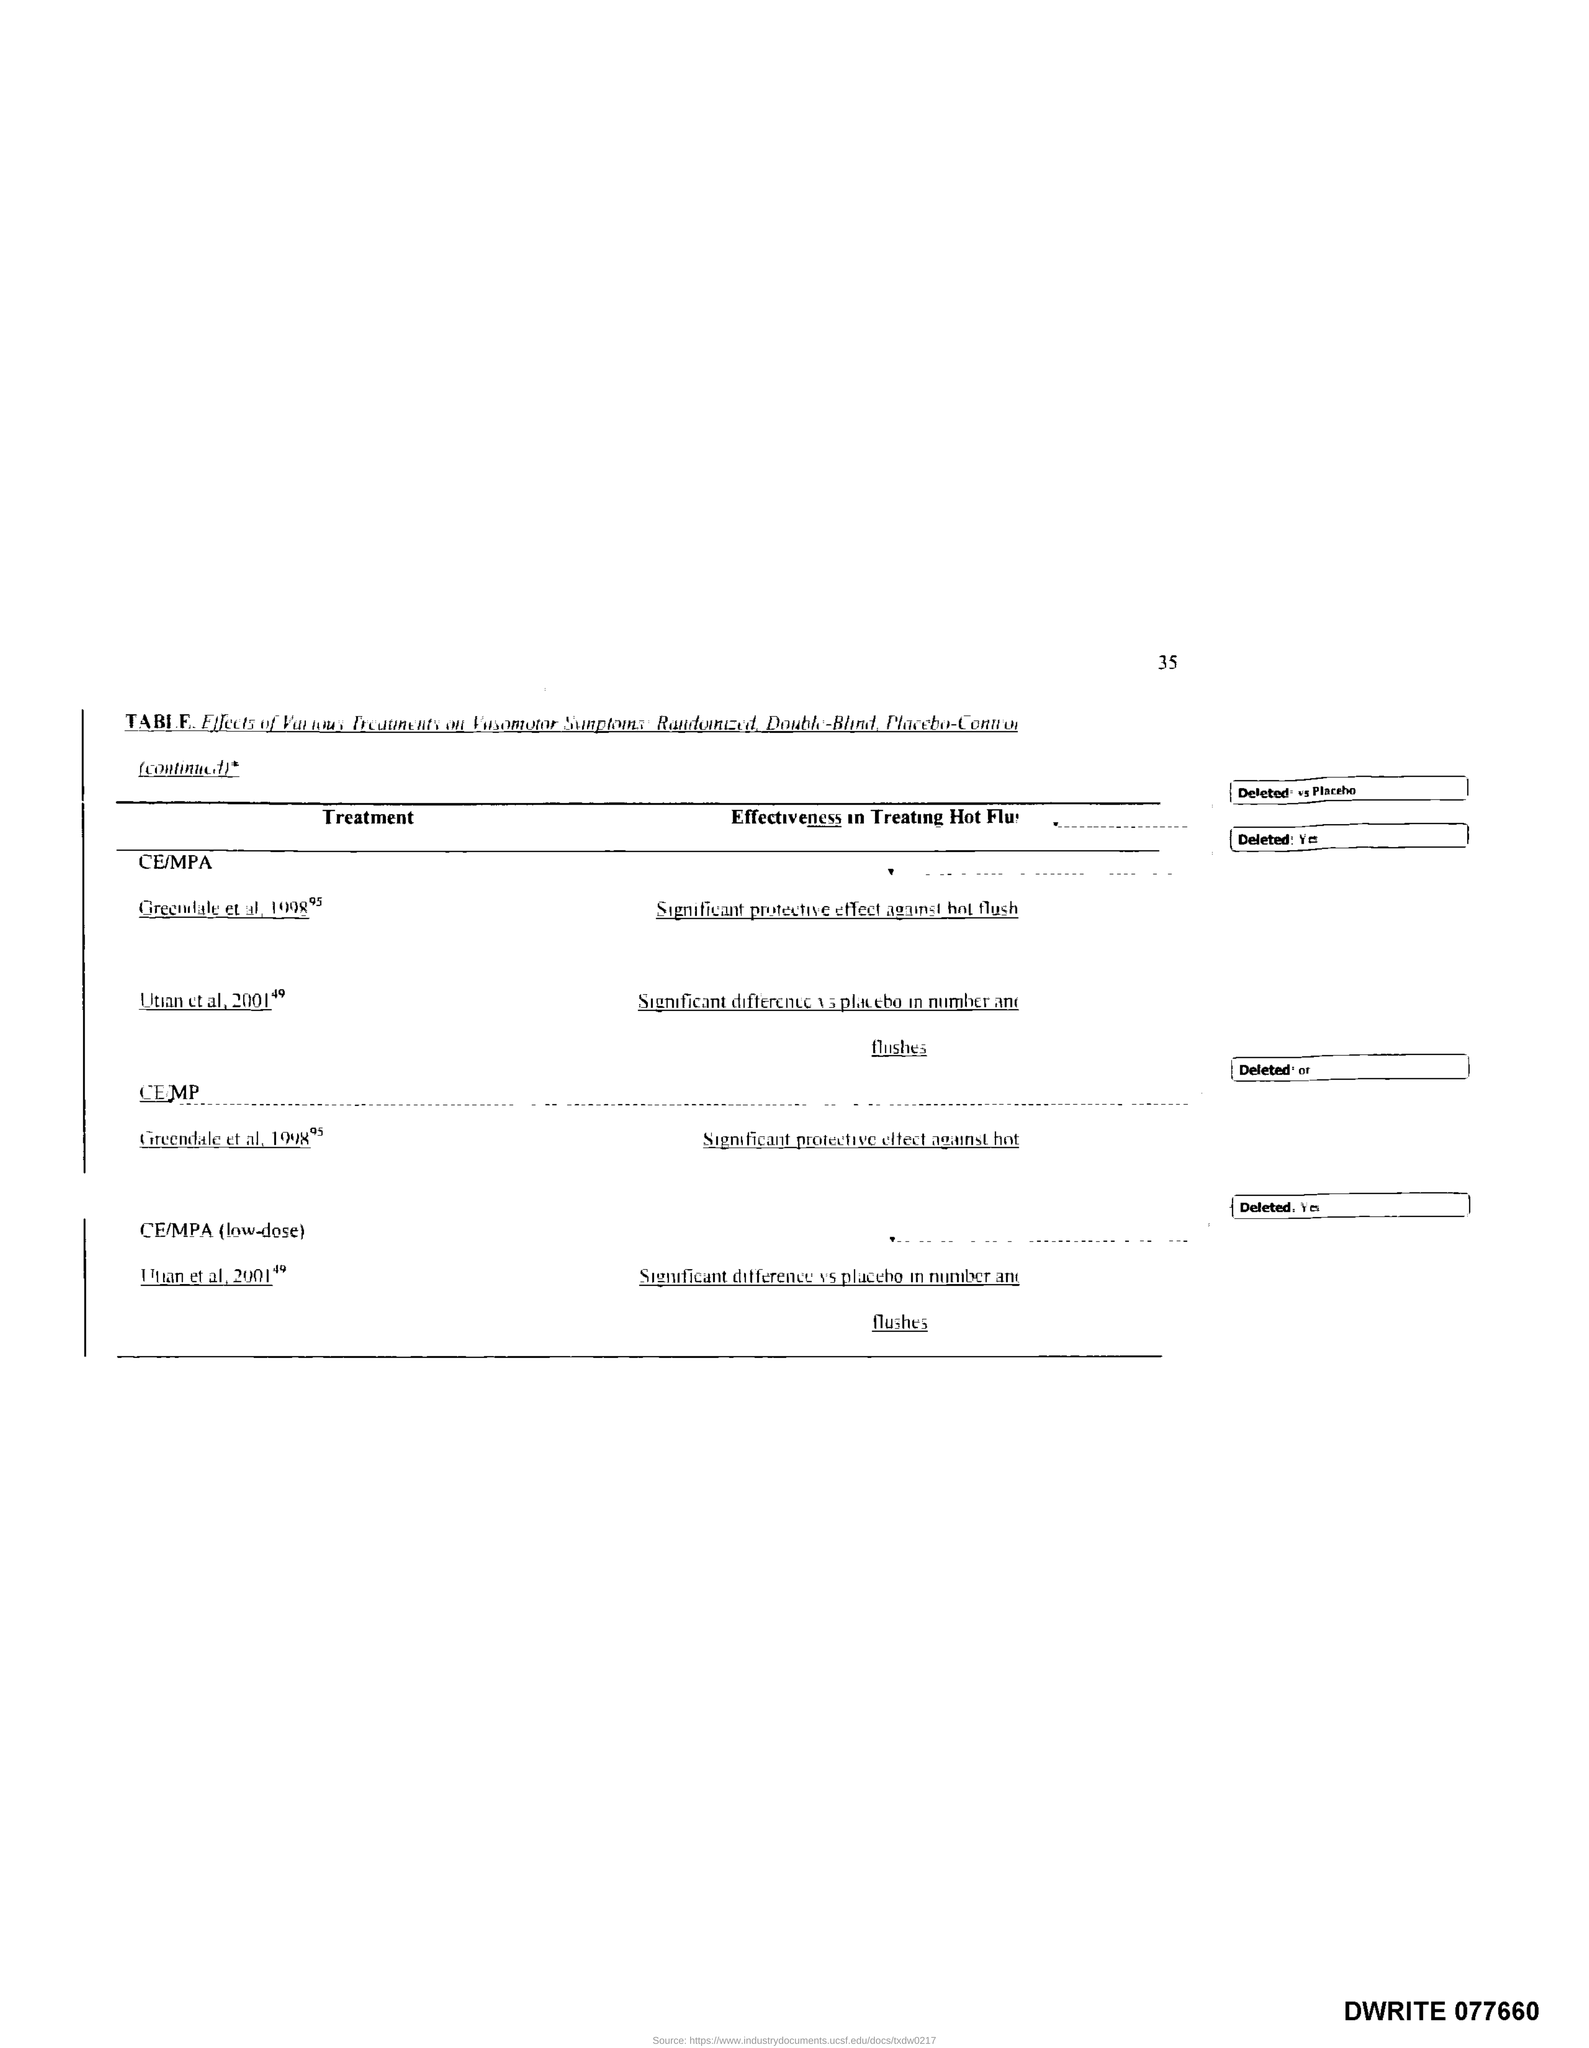Specify some key components in this picture. What is the document number?" the foreman asked, holding up a slip of paper with the number 077660 written on it in bold letters. The page number is 35. 